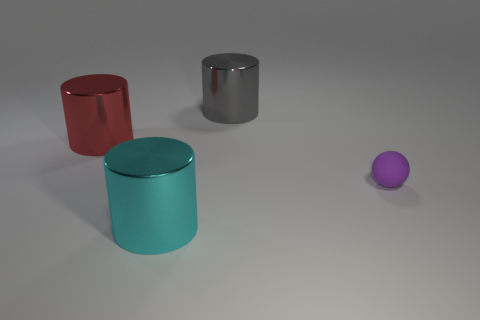Add 2 purple matte objects. How many objects exist? 6 Subtract 1 cylinders. How many cylinders are left? 2 Subtract all spheres. How many objects are left? 3 Subtract all small red objects. Subtract all purple rubber objects. How many objects are left? 3 Add 4 large metal cylinders. How many large metal cylinders are left? 7 Add 4 big blue metal cubes. How many big blue metal cubes exist? 4 Subtract 0 red spheres. How many objects are left? 4 